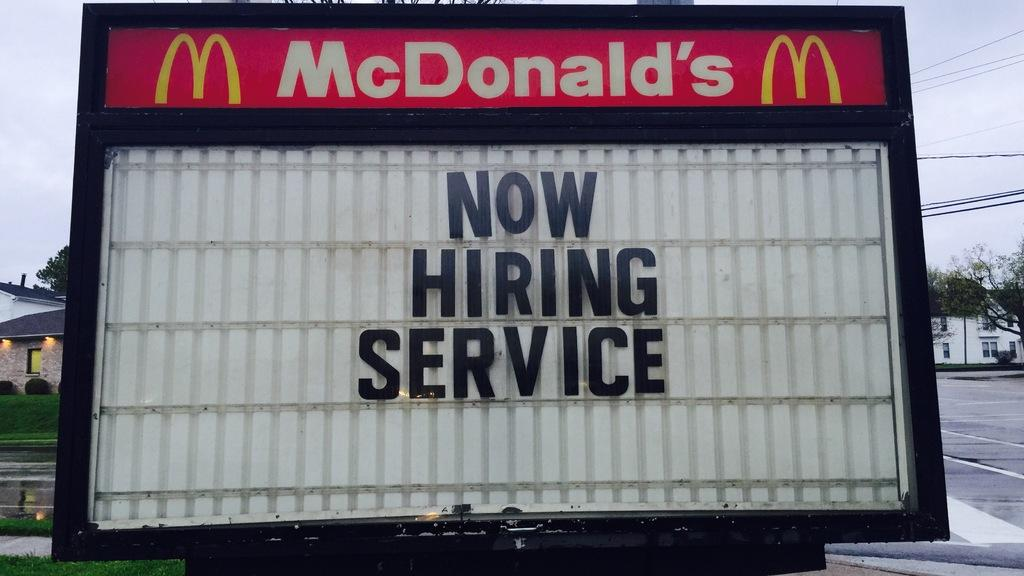Provide a one-sentence caption for the provided image. A McDonald's sign that says "Now Hiring Service.". 